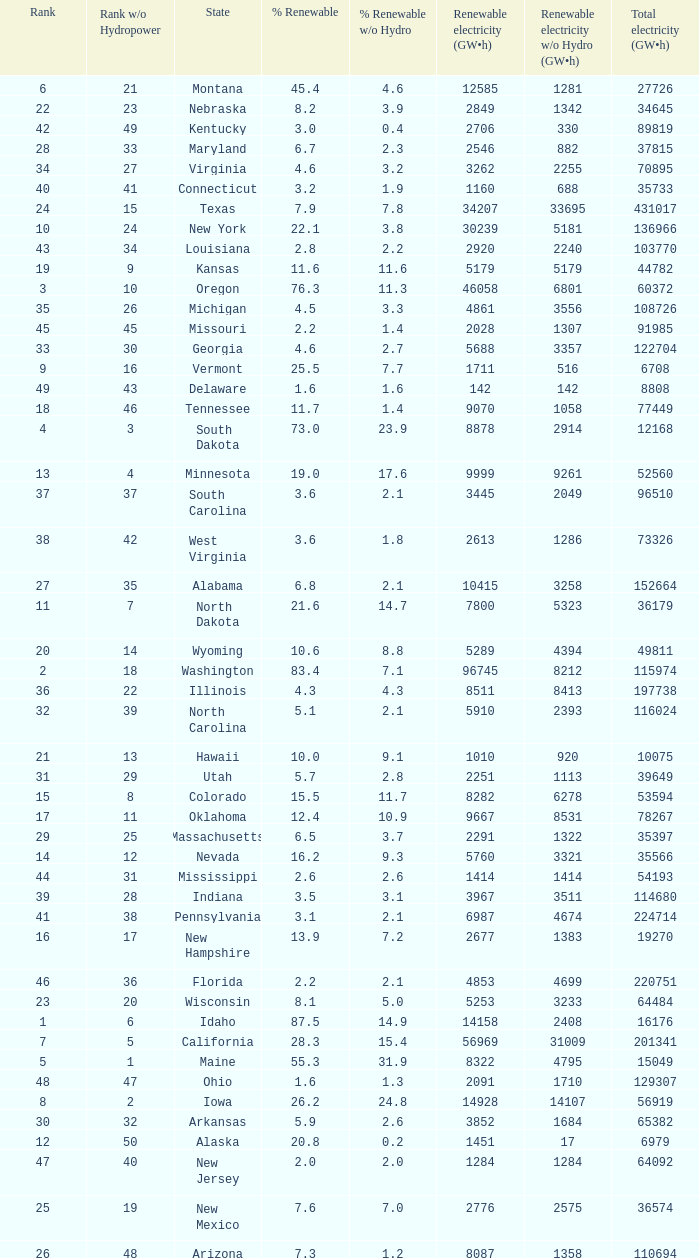What is the percentage of renewable electricity without hydrogen power in the state of South Dakota? 23.9. 